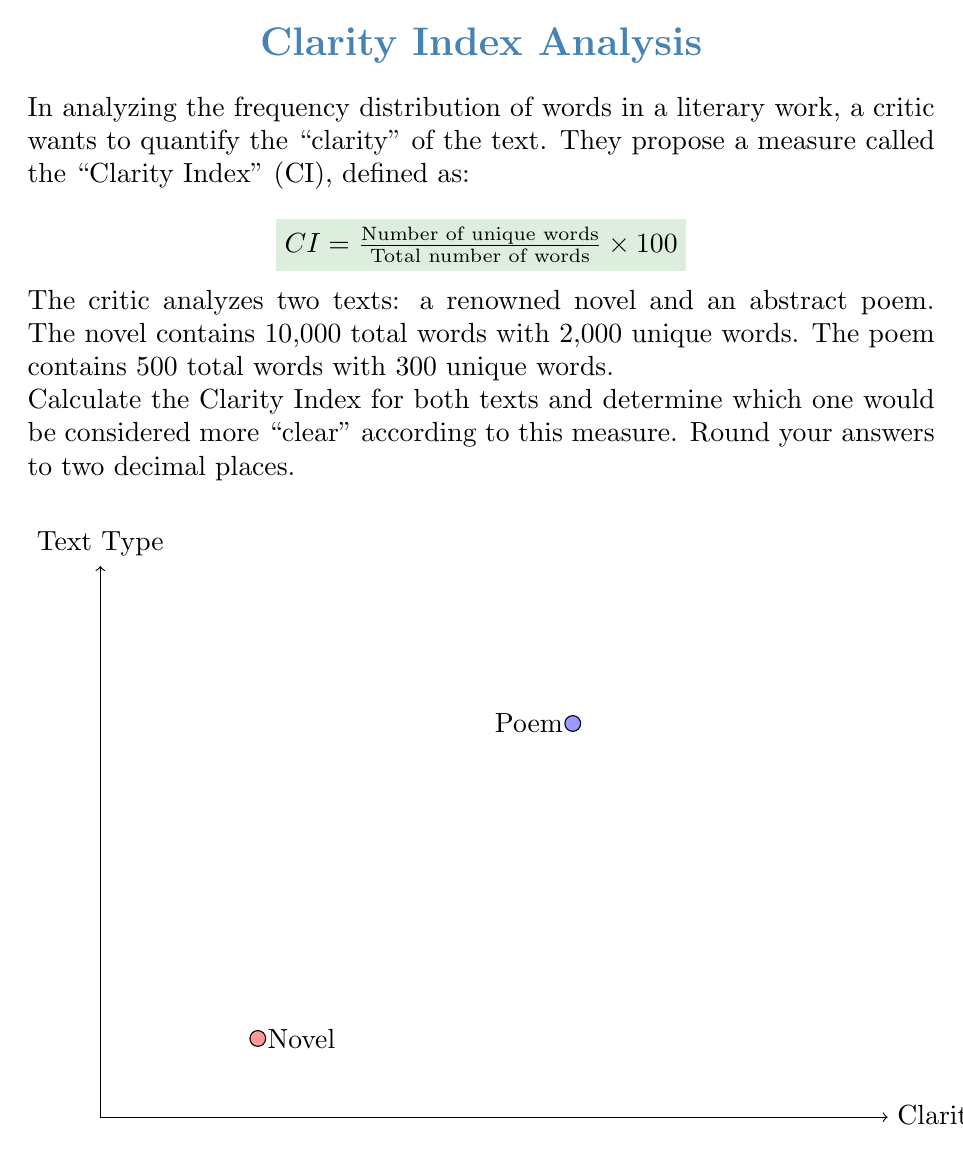Could you help me with this problem? Let's solve this problem step-by-step:

1) First, let's recall the formula for the Clarity Index (CI):
   $$ CI = \frac{\text{Number of unique words}}{\text{Total number of words}} \times 100 $$

2) For the novel:
   - Total words: 10,000
   - Unique words: 2,000
   
   $$ CI_{novel} = \frac{2,000}{10,000} \times 100 = 0.2 \times 100 = 20.00 $$

3) For the poem:
   - Total words: 500
   - Unique words: 300
   
   $$ CI_{poem} = \frac{300}{500} \times 100 = 0.6 \times 100 = 60.00 $$

4) Comparing the two:
   - Novel CI: 20.00
   - Poem CI: 60.00

5) The higher Clarity Index indicates a higher proportion of unique words, which according to this measure, would be considered more "clear".

6) Therefore, the poem has a higher Clarity Index and would be considered more "clear" according to this measure.

This result might seem counterintuitive to our literary critic, who believes that abstract art (and by extension, abstract poetry) lacks clarity. This demonstrates a limitation of using purely quantitative measures to assess literary quality or clarity.
Answer: Poem CI: 60.00, Novel CI: 20.00. Poem is "clearer". 